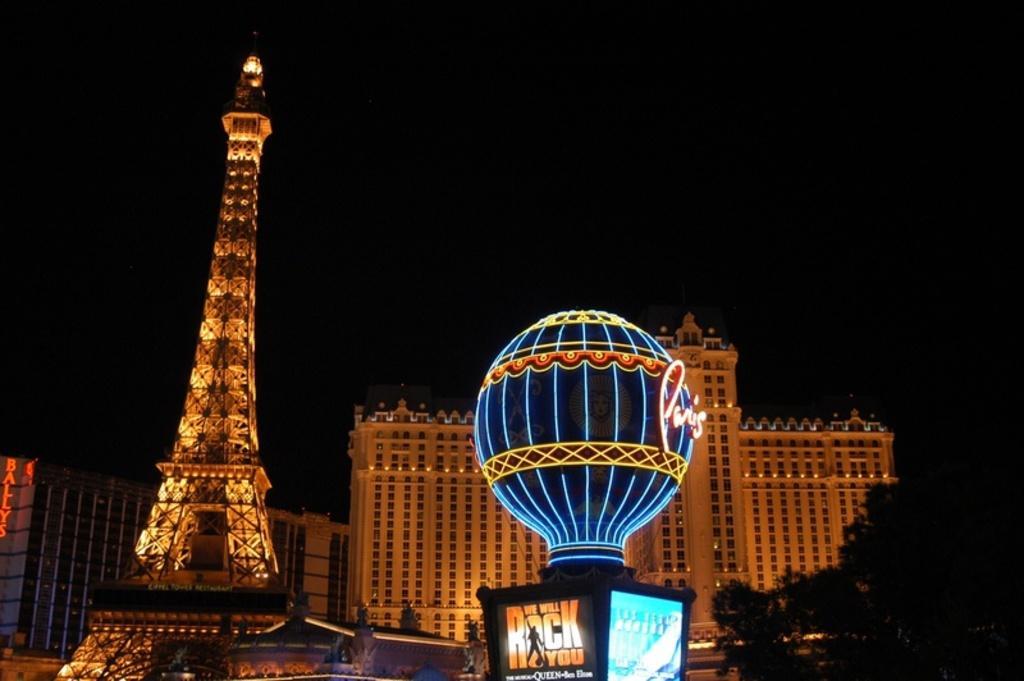Please provide a concise description of this image. In this image on the foreground there are lighting, tower. In the background there are buildings, trees. 